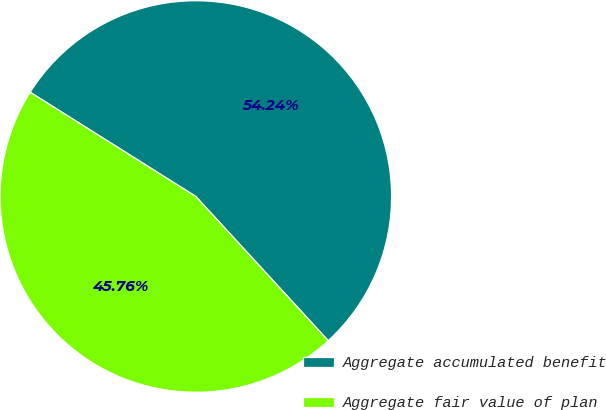Convert chart. <chart><loc_0><loc_0><loc_500><loc_500><pie_chart><fcel>Aggregate accumulated benefit<fcel>Aggregate fair value of plan<nl><fcel>54.24%<fcel>45.76%<nl></chart> 